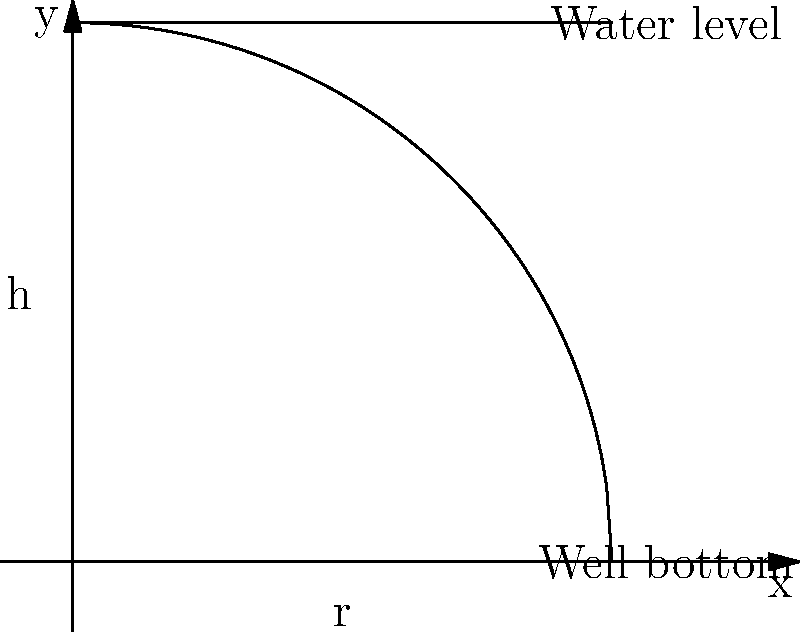In an ancient city, archaeologists discovered a cylindrical well with a radius of 5 meters. The well needs to be emptied for further excavation. If the current water level is 5 meters above the bottom of the well, calculate the work done to pump all the water out of the well. Assume the density of water is 1000 kg/m³ and the acceleration due to gravity is 9.8 m/s². How does this calculation reflect the engineering challenges faced by ancient civilizations in water management? Let's approach this step-by-step:

1) The work done to pump water out of a well is given by the formula:

   $$W = \int_0^h \rho g \pi r^2 y dy$$

   Where:
   $W$ is work done
   $\rho$ is density of water
   $g$ is acceleration due to gravity
   $r$ is radius of the well
   $h$ is height of water
   $y$ is variable of integration

2) We're given:
   $\rho = 1000$ kg/m³
   $g = 9.8$ m/s²
   $r = 5$ m
   $h = 5$ m

3) Substituting these values:

   $$W = \int_0^5 1000 \cdot 9.8 \cdot \pi \cdot 5^2 \cdot y dy$$

4) Simplify the constants:

   $$W = 765500\pi \int_0^5 y dy$$

5) Integrate:

   $$W = 765500\pi \left[\frac{y^2}{2}\right]_0^5$$

6) Evaluate the integral:

   $$W = 765500\pi \left(\frac{25}{2} - 0\right) = 9568750\pi$$

7) Calculate the final value:

   $$W = 30053698.75 \text{ J} \approx 30.05 \text{ MJ}$$

This calculation reflects the significant effort required by ancient civilizations to manage water resources. The large amount of work needed to empty even a single well demonstrates the challenges they faced in water extraction, distribution, and management, highlighting the importance of efficient engineering solutions in ancient urban planning and development.
Answer: 30.05 MJ 